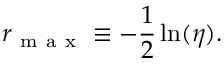<formula> <loc_0><loc_0><loc_500><loc_500>r _ { m a x } \equiv - \frac { 1 } { 2 } \ln ( \eta ) .</formula> 